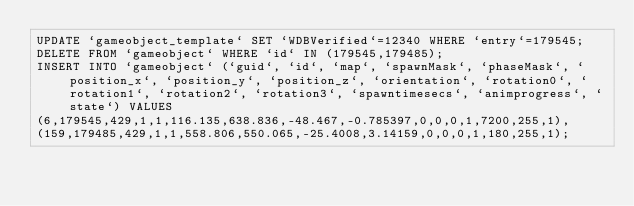Convert code to text. <code><loc_0><loc_0><loc_500><loc_500><_SQL_>UPDATE `gameobject_template` SET `WDBVerified`=12340 WHERE `entry`=179545;
DELETE FROM `gameobject` WHERE `id` IN (179545,179485);
INSERT INTO `gameobject` (`guid`, `id`, `map`, `spawnMask`, `phaseMask`, `position_x`, `position_y`, `position_z`, `orientation`, `rotation0`, `rotation1`, `rotation2`, `rotation3`, `spawntimesecs`, `animprogress`, `state`) VALUES
(6,179545,429,1,1,116.135,638.836,-48.467,-0.785397,0,0,0,1,7200,255,1),
(159,179485,429,1,1,558.806,550.065,-25.4008,3.14159,0,0,0,1,180,255,1);</code> 